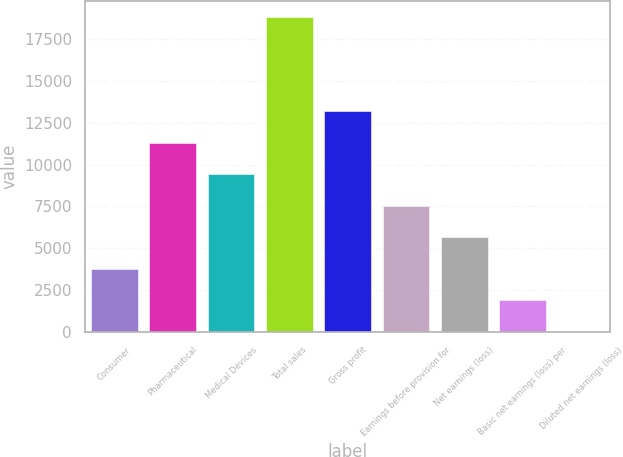Convert chart. <chart><loc_0><loc_0><loc_500><loc_500><bar_chart><fcel>Consumer<fcel>Pharmaceutical<fcel>Medical Devices<fcel>Total sales<fcel>Gross profit<fcel>Earnings before provision for<fcel>Net earnings (loss)<fcel>Basic net earnings (loss) per<fcel>Diluted net earnings (loss)<nl><fcel>3768.92<fcel>11304<fcel>9420.2<fcel>18839<fcel>13187.7<fcel>7536.44<fcel>5652.68<fcel>1885.16<fcel>1.4<nl></chart> 